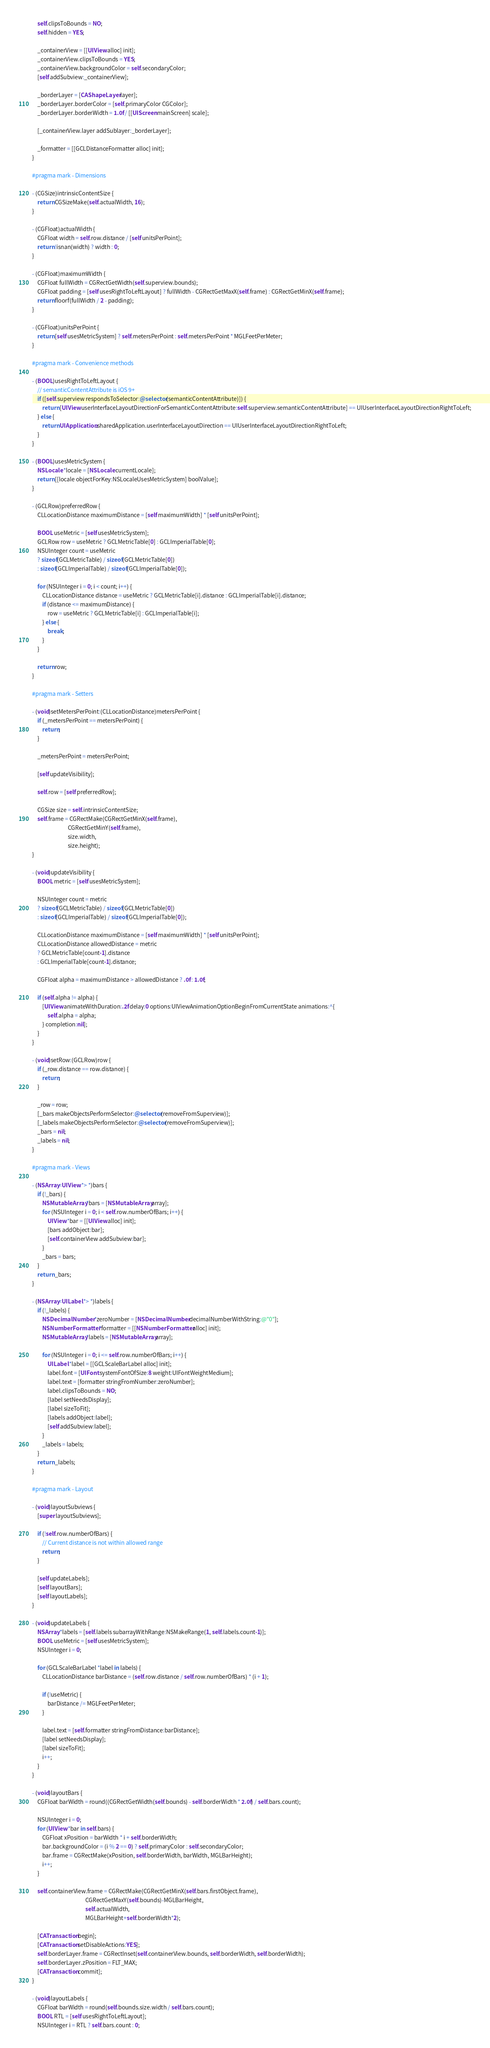Convert code to text. <code><loc_0><loc_0><loc_500><loc_500><_ObjectiveC_>    self.clipsToBounds = NO;
    self.hidden = YES;
    
    _containerView = [[UIView alloc] init];
    _containerView.clipsToBounds = YES;
    _containerView.backgroundColor = self.secondaryColor;
    [self addSubview:_containerView];
    
    _borderLayer = [CAShapeLayer layer];
    _borderLayer.borderColor = [self.primaryColor CGColor];
    _borderLayer.borderWidth = 1.0f / [[UIScreen mainScreen] scale];
    
    [_containerView.layer addSublayer:_borderLayer];
    
    _formatter = [[GCLDistanceFormatter alloc] init];
}

#pragma mark - Dimensions

- (CGSize)intrinsicContentSize {
    return CGSizeMake(self.actualWidth, 16);
}

- (CGFloat)actualWidth {
    CGFloat width = self.row.distance / [self unitsPerPoint];
    return !isnan(width) ? width : 0;
}

- (CGFloat)maximumWidth {
    CGFloat fullWidth = CGRectGetWidth(self.superview.bounds);
    CGFloat padding = [self usesRightToLeftLayout] ? fullWidth - CGRectGetMaxX(self.frame) : CGRectGetMinX(self.frame);
    return floorf(fullWidth / 2 - padding);
}

- (CGFloat)unitsPerPoint {
    return [self usesMetricSystem] ? self.metersPerPoint : self.metersPerPoint * MGLFeetPerMeter;
}

#pragma mark - Convenience methods

- (BOOL)usesRightToLeftLayout {
    // semanticContentAttribute is iOS 9+
    if ([self.superview respondsToSelector:@selector(semanticContentAttribute)]) {
        return [UIView userInterfaceLayoutDirectionForSemanticContentAttribute:self.superview.semanticContentAttribute] == UIUserInterfaceLayoutDirectionRightToLeft;
    } else {
        return UIApplication.sharedApplication.userInterfaceLayoutDirection == UIUserInterfaceLayoutDirectionRightToLeft;
    }
}

- (BOOL)usesMetricSystem {
    NSLocale *locale = [NSLocale currentLocale];
    return [[locale objectForKey:NSLocaleUsesMetricSystem] boolValue];
}

- (GCLRow)preferredRow {
    CLLocationDistance maximumDistance = [self maximumWidth] * [self unitsPerPoint];
    
    BOOL useMetric = [self usesMetricSystem];
    GCLRow row = useMetric ? GCLMetricTable[0] : GCLImperialTable[0];
    NSUInteger count = useMetric
    ? sizeof(GCLMetricTable) / sizeof(GCLMetricTable[0])
    : sizeof(GCLImperialTable) / sizeof(GCLImperialTable[0]);
    
    for (NSUInteger i = 0; i < count; i++) {
        CLLocationDistance distance = useMetric ? GCLMetricTable[i].distance : GCLImperialTable[i].distance;
        if (distance <= maximumDistance) {
            row = useMetric ? GCLMetricTable[i] : GCLImperialTable[i];
        } else {
            break;
        }
    }
    
    return row;
}

#pragma mark - Setters

- (void)setMetersPerPoint:(CLLocationDistance)metersPerPoint {
    if (_metersPerPoint == metersPerPoint) {
        return;
    }
    
    _metersPerPoint = metersPerPoint;
    
    [self updateVisibility];
    
    self.row = [self preferredRow];
    
    CGSize size = self.intrinsicContentSize;
    self.frame = CGRectMake(CGRectGetMinX(self.frame),
                            CGRectGetMinY(self.frame),
                            size.width,
                            size.height);
}

- (void)updateVisibility {
    BOOL metric = [self usesMetricSystem];
    
    NSUInteger count = metric
    ? sizeof(GCLMetricTable) / sizeof(GCLMetricTable[0])
    : sizeof(GCLImperialTable) / sizeof(GCLImperialTable[0]);
    
    CLLocationDistance maximumDistance = [self maximumWidth] * [self unitsPerPoint];
    CLLocationDistance allowedDistance = metric
    ? GCLMetricTable[count-1].distance
    : GCLImperialTable[count-1].distance;
    
    CGFloat alpha = maximumDistance > allowedDistance ? .0f : 1.0f;
    
    if (self.alpha != alpha) {
        [UIView animateWithDuration:.2f delay:0 options:UIViewAnimationOptionBeginFromCurrentState animations:^{
            self.alpha = alpha;
        } completion:nil];
    }
}

- (void)setRow:(GCLRow)row {
    if (_row.distance == row.distance) {
        return;
    }
    
    _row = row;
    [_bars makeObjectsPerformSelector:@selector(removeFromSuperview)];
    [_labels makeObjectsPerformSelector:@selector(removeFromSuperview)];
    _bars = nil;
    _labels = nil;
}

#pragma mark - Views

- (NSArray<UIView *> *)bars {
    if (!_bars) {
        NSMutableArray *bars = [NSMutableArray array];
        for (NSUInteger i = 0; i < self.row.numberOfBars; i++) {
            UIView *bar = [[UIView alloc] init];
            [bars addObject:bar];
            [self.containerView addSubview:bar];
        }
        _bars = bars;
    }
    return _bars;
}

- (NSArray<UILabel *> *)labels {
    if (!_labels) {
        NSDecimalNumber *zeroNumber = [NSDecimalNumber decimalNumberWithString:@"0"];
        NSNumberFormatter *formatter = [[NSNumberFormatter alloc] init];
        NSMutableArray *labels = [NSMutableArray array];
        
        for (NSUInteger i = 0; i <= self.row.numberOfBars; i++) {
            UILabel *label = [[GCLScaleBarLabel alloc] init];
            label.font = [UIFont systemFontOfSize:8 weight:UIFontWeightMedium];
            label.text = [formatter stringFromNumber:zeroNumber];
            label.clipsToBounds = NO;
            [label setNeedsDisplay];
            [label sizeToFit];
            [labels addObject:label];
            [self addSubview:label];
        }
        _labels = labels;
    }
    return _labels;
}

#pragma mark - Layout

- (void)layoutSubviews {
    [super layoutSubviews];
    
    if (!self.row.numberOfBars) {
        // Current distance is not within allowed range
        return;
    }
    
    [self updateLabels];
    [self layoutBars];
    [self layoutLabels];
}

- (void)updateLabels {
    NSArray *labels = [self.labels subarrayWithRange:NSMakeRange(1, self.labels.count-1)];
    BOOL useMetric = [self usesMetricSystem];
    NSUInteger i = 0;
    
    for (GCLScaleBarLabel *label in labels) {
        CLLocationDistance barDistance = (self.row.distance / self.row.numberOfBars) * (i + 1);
        
        if (!useMetric) {
            barDistance /= MGLFeetPerMeter;
        }
        
        label.text = [self.formatter stringFromDistance:barDistance];
        [label setNeedsDisplay];
        [label sizeToFit];
        i++;
    }
}

- (void)layoutBars {
    CGFloat barWidth = round((CGRectGetWidth(self.bounds) - self.borderWidth * 2.0f) / self.bars.count);
    
    NSUInteger i = 0;
    for (UIView *bar in self.bars) {
        CGFloat xPosition = barWidth * i + self.borderWidth;
        bar.backgroundColor = (i % 2 == 0) ? self.primaryColor : self.secondaryColor;
        bar.frame = CGRectMake(xPosition, self.borderWidth, barWidth, MGLBarHeight);
        i++;
    }
    
    self.containerView.frame = CGRectMake(CGRectGetMinX(self.bars.firstObject.frame),
                                          CGRectGetMaxY(self.bounds)-MGLBarHeight,
                                          self.actualWidth,
                                          MGLBarHeight+self.borderWidth*2);
    
    [CATransaction begin];
    [CATransaction setDisableActions:YES];
    self.borderLayer.frame = CGRectInset(self.containerView.bounds, self.borderWidth, self.borderWidth);
    self.borderLayer.zPosition = FLT_MAX;
    [CATransaction commit];
}

- (void)layoutLabels {
    CGFloat barWidth = round(self.bounds.size.width / self.bars.count);
    BOOL RTL = [self usesRightToLeftLayout];
    NSUInteger i = RTL ? self.bars.count : 0;</code> 